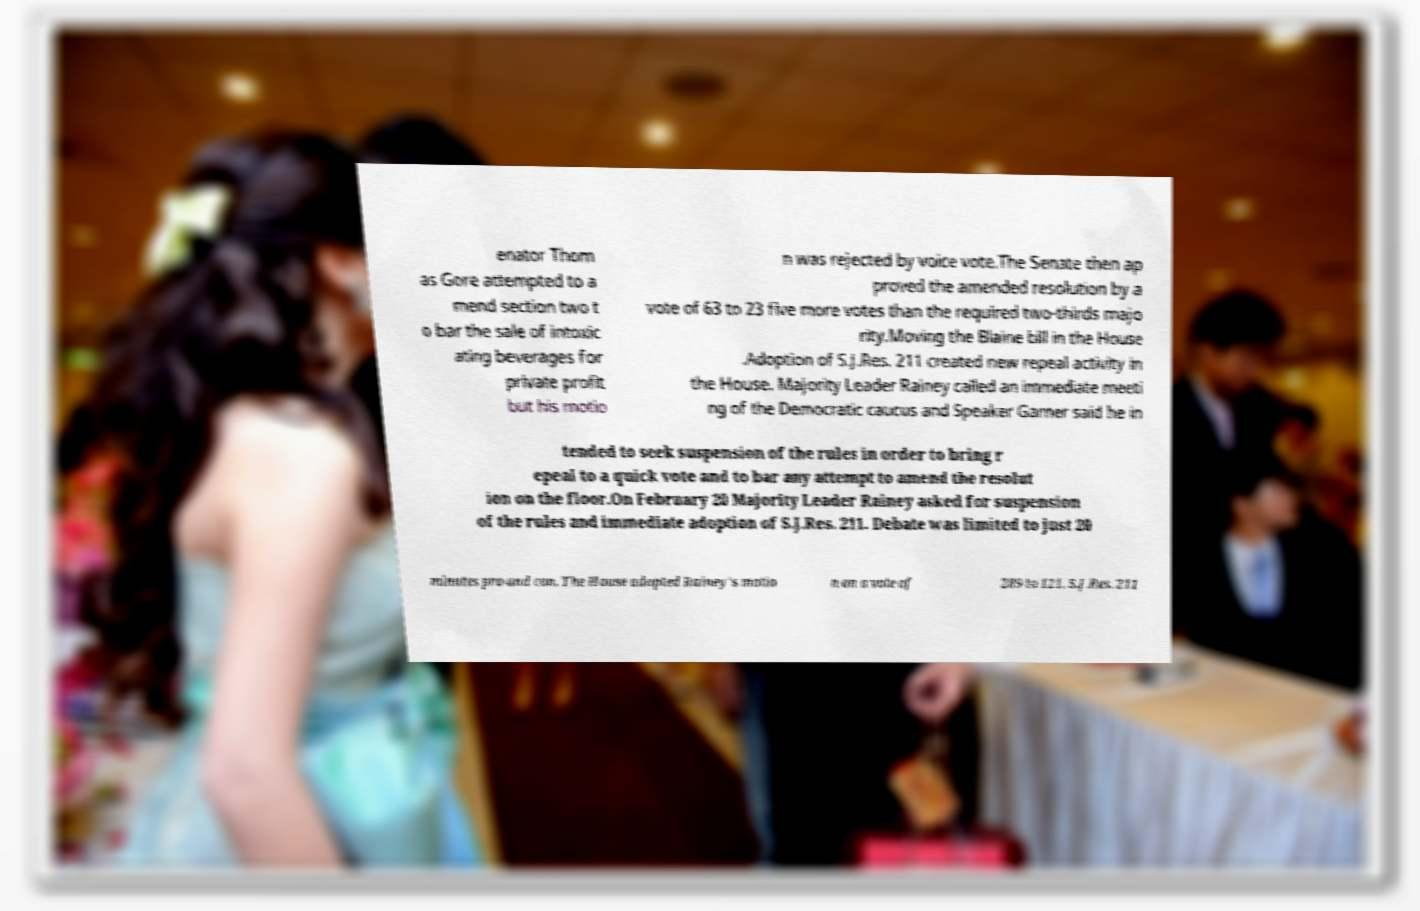Please identify and transcribe the text found in this image. enator Thom as Gore attempted to a mend section two t o bar the sale of intoxic ating beverages for private profit but his motio n was rejected by voice vote.The Senate then ap proved the amended resolution by a vote of 63 to 23 five more votes than the required two-thirds majo rity.Moving the Blaine bill in the House .Adoption of S.J.Res. 211 created new repeal activity in the House. Majority Leader Rainey called an immediate meeti ng of the Democratic caucus and Speaker Garner said he in tended to seek suspension of the rules in order to bring r epeal to a quick vote and to bar any attempt to amend the resolut ion on the floor.On February 20 Majority Leader Rainey asked for suspension of the rules and immediate adoption of S.J.Res. 211. Debate was limited to just 20 minutes pro and con. The House adopted Rainey's motio n on a vote of 289 to 121. S.J.Res. 211 